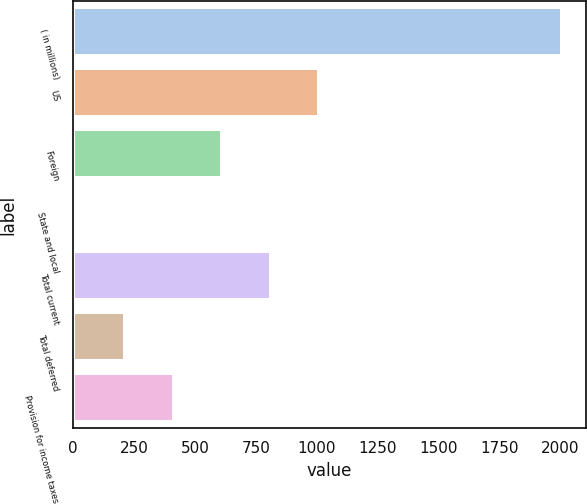Convert chart. <chart><loc_0><loc_0><loc_500><loc_500><bar_chart><fcel>( in millions)<fcel>US<fcel>Foreign<fcel>State and local<fcel>Total current<fcel>Total deferred<fcel>Provision for income taxes<nl><fcel>2005<fcel>1010.15<fcel>612.21<fcel>15.3<fcel>811.18<fcel>214.27<fcel>413.24<nl></chart> 